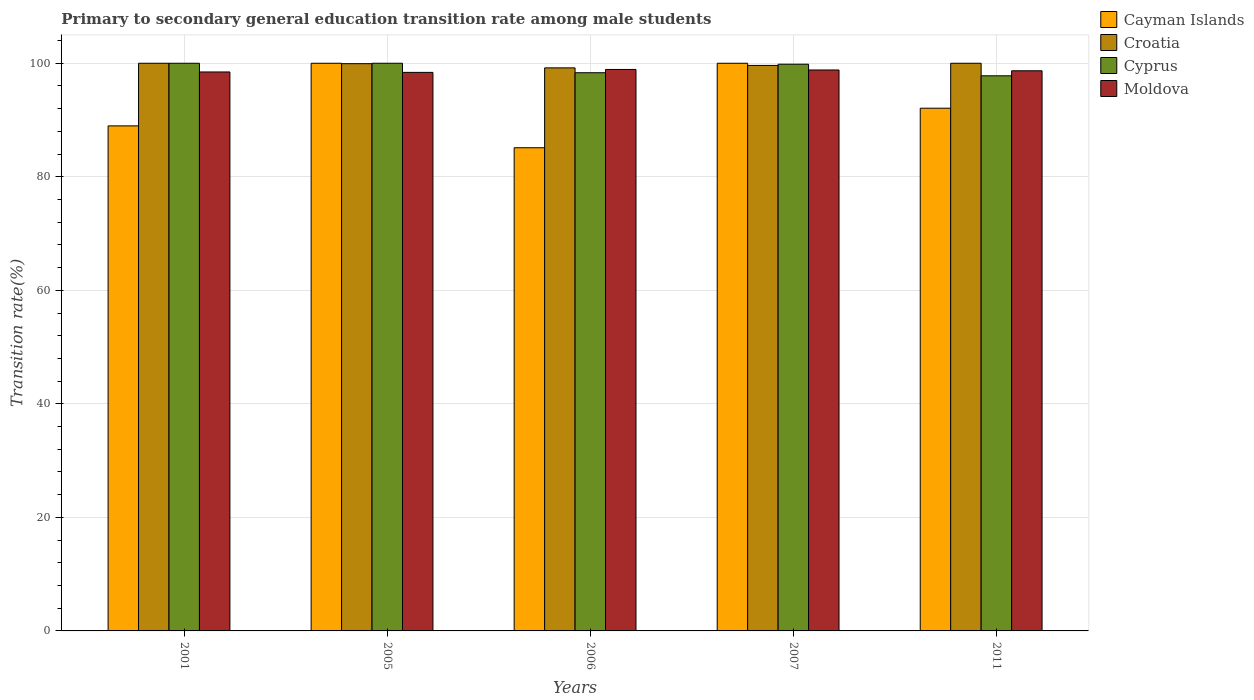How many different coloured bars are there?
Your answer should be compact. 4. How many groups of bars are there?
Provide a succinct answer. 5. How many bars are there on the 2nd tick from the right?
Offer a very short reply. 4. What is the label of the 1st group of bars from the left?
Your answer should be compact. 2001. In how many cases, is the number of bars for a given year not equal to the number of legend labels?
Your answer should be compact. 0. What is the transition rate in Moldova in 2007?
Give a very brief answer. 98.82. Across all years, what is the maximum transition rate in Cyprus?
Provide a succinct answer. 100. Across all years, what is the minimum transition rate in Cyprus?
Give a very brief answer. 97.79. In which year was the transition rate in Moldova minimum?
Your answer should be very brief. 2005. What is the total transition rate in Moldova in the graph?
Make the answer very short. 493.26. What is the difference between the transition rate in Croatia in 2006 and that in 2011?
Offer a terse response. -0.81. What is the difference between the transition rate in Cyprus in 2011 and the transition rate in Croatia in 2001?
Offer a very short reply. -2.21. What is the average transition rate in Croatia per year?
Keep it short and to the point. 99.75. In the year 2005, what is the difference between the transition rate in Croatia and transition rate in Cayman Islands?
Keep it short and to the point. -0.07. What is the ratio of the transition rate in Cyprus in 2001 to that in 2007?
Ensure brevity in your answer.  1. Is the transition rate in Cayman Islands in 2001 less than that in 2011?
Ensure brevity in your answer.  Yes. What is the difference between the highest and the lowest transition rate in Cyprus?
Keep it short and to the point. 2.21. In how many years, is the transition rate in Cayman Islands greater than the average transition rate in Cayman Islands taken over all years?
Keep it short and to the point. 2. Is the sum of the transition rate in Cyprus in 2005 and 2007 greater than the maximum transition rate in Cayman Islands across all years?
Ensure brevity in your answer.  Yes. Is it the case that in every year, the sum of the transition rate in Moldova and transition rate in Cayman Islands is greater than the sum of transition rate in Croatia and transition rate in Cyprus?
Offer a terse response. No. What does the 3rd bar from the left in 2006 represents?
Provide a short and direct response. Cyprus. What does the 3rd bar from the right in 2006 represents?
Provide a short and direct response. Croatia. How many bars are there?
Your answer should be compact. 20. Are all the bars in the graph horizontal?
Provide a succinct answer. No. Are the values on the major ticks of Y-axis written in scientific E-notation?
Give a very brief answer. No. Does the graph contain any zero values?
Provide a short and direct response. No. How many legend labels are there?
Give a very brief answer. 4. How are the legend labels stacked?
Offer a terse response. Vertical. What is the title of the graph?
Your answer should be compact. Primary to secondary general education transition rate among male students. Does "Nicaragua" appear as one of the legend labels in the graph?
Make the answer very short. No. What is the label or title of the X-axis?
Provide a succinct answer. Years. What is the label or title of the Y-axis?
Your answer should be very brief. Transition rate(%). What is the Transition rate(%) in Cayman Islands in 2001?
Provide a succinct answer. 88.97. What is the Transition rate(%) of Croatia in 2001?
Your answer should be very brief. 100. What is the Transition rate(%) in Moldova in 2001?
Keep it short and to the point. 98.47. What is the Transition rate(%) of Croatia in 2005?
Make the answer very short. 99.93. What is the Transition rate(%) of Moldova in 2005?
Your answer should be compact. 98.39. What is the Transition rate(%) in Cayman Islands in 2006?
Ensure brevity in your answer.  85.12. What is the Transition rate(%) of Croatia in 2006?
Make the answer very short. 99.19. What is the Transition rate(%) in Cyprus in 2006?
Give a very brief answer. 98.33. What is the Transition rate(%) of Moldova in 2006?
Ensure brevity in your answer.  98.91. What is the Transition rate(%) of Croatia in 2007?
Your answer should be very brief. 99.62. What is the Transition rate(%) of Cyprus in 2007?
Provide a succinct answer. 99.83. What is the Transition rate(%) of Moldova in 2007?
Your answer should be compact. 98.82. What is the Transition rate(%) of Cayman Islands in 2011?
Your response must be concise. 92.08. What is the Transition rate(%) in Cyprus in 2011?
Give a very brief answer. 97.79. What is the Transition rate(%) of Moldova in 2011?
Offer a very short reply. 98.67. Across all years, what is the maximum Transition rate(%) in Cayman Islands?
Make the answer very short. 100. Across all years, what is the maximum Transition rate(%) of Cyprus?
Your response must be concise. 100. Across all years, what is the maximum Transition rate(%) in Moldova?
Provide a succinct answer. 98.91. Across all years, what is the minimum Transition rate(%) in Cayman Islands?
Offer a very short reply. 85.12. Across all years, what is the minimum Transition rate(%) of Croatia?
Your answer should be very brief. 99.19. Across all years, what is the minimum Transition rate(%) in Cyprus?
Keep it short and to the point. 97.79. Across all years, what is the minimum Transition rate(%) of Moldova?
Ensure brevity in your answer.  98.39. What is the total Transition rate(%) of Cayman Islands in the graph?
Make the answer very short. 466.17. What is the total Transition rate(%) in Croatia in the graph?
Ensure brevity in your answer.  498.73. What is the total Transition rate(%) in Cyprus in the graph?
Give a very brief answer. 495.95. What is the total Transition rate(%) in Moldova in the graph?
Your answer should be compact. 493.26. What is the difference between the Transition rate(%) of Cayman Islands in 2001 and that in 2005?
Ensure brevity in your answer.  -11.03. What is the difference between the Transition rate(%) of Croatia in 2001 and that in 2005?
Give a very brief answer. 0.07. What is the difference between the Transition rate(%) of Cyprus in 2001 and that in 2005?
Give a very brief answer. 0. What is the difference between the Transition rate(%) of Moldova in 2001 and that in 2005?
Keep it short and to the point. 0.07. What is the difference between the Transition rate(%) of Cayman Islands in 2001 and that in 2006?
Offer a terse response. 3.85. What is the difference between the Transition rate(%) of Croatia in 2001 and that in 2006?
Make the answer very short. 0.81. What is the difference between the Transition rate(%) in Cyprus in 2001 and that in 2006?
Offer a very short reply. 1.67. What is the difference between the Transition rate(%) in Moldova in 2001 and that in 2006?
Offer a terse response. -0.44. What is the difference between the Transition rate(%) of Cayman Islands in 2001 and that in 2007?
Your response must be concise. -11.03. What is the difference between the Transition rate(%) of Croatia in 2001 and that in 2007?
Offer a very short reply. 0.38. What is the difference between the Transition rate(%) in Cyprus in 2001 and that in 2007?
Offer a terse response. 0.17. What is the difference between the Transition rate(%) in Moldova in 2001 and that in 2007?
Your response must be concise. -0.35. What is the difference between the Transition rate(%) of Cayman Islands in 2001 and that in 2011?
Provide a short and direct response. -3.11. What is the difference between the Transition rate(%) of Cyprus in 2001 and that in 2011?
Offer a very short reply. 2.21. What is the difference between the Transition rate(%) in Moldova in 2001 and that in 2011?
Offer a terse response. -0.21. What is the difference between the Transition rate(%) in Cayman Islands in 2005 and that in 2006?
Make the answer very short. 14.88. What is the difference between the Transition rate(%) in Croatia in 2005 and that in 2006?
Provide a short and direct response. 0.74. What is the difference between the Transition rate(%) in Cyprus in 2005 and that in 2006?
Your answer should be compact. 1.67. What is the difference between the Transition rate(%) of Moldova in 2005 and that in 2006?
Keep it short and to the point. -0.51. What is the difference between the Transition rate(%) in Croatia in 2005 and that in 2007?
Make the answer very short. 0.31. What is the difference between the Transition rate(%) in Cyprus in 2005 and that in 2007?
Your answer should be very brief. 0.17. What is the difference between the Transition rate(%) of Moldova in 2005 and that in 2007?
Offer a very short reply. -0.42. What is the difference between the Transition rate(%) of Cayman Islands in 2005 and that in 2011?
Offer a terse response. 7.92. What is the difference between the Transition rate(%) in Croatia in 2005 and that in 2011?
Offer a terse response. -0.07. What is the difference between the Transition rate(%) of Cyprus in 2005 and that in 2011?
Your answer should be very brief. 2.21. What is the difference between the Transition rate(%) of Moldova in 2005 and that in 2011?
Offer a terse response. -0.28. What is the difference between the Transition rate(%) of Cayman Islands in 2006 and that in 2007?
Your answer should be very brief. -14.88. What is the difference between the Transition rate(%) in Croatia in 2006 and that in 2007?
Give a very brief answer. -0.43. What is the difference between the Transition rate(%) of Cyprus in 2006 and that in 2007?
Your response must be concise. -1.5. What is the difference between the Transition rate(%) of Moldova in 2006 and that in 2007?
Your answer should be compact. 0.09. What is the difference between the Transition rate(%) of Cayman Islands in 2006 and that in 2011?
Make the answer very short. -6.97. What is the difference between the Transition rate(%) in Croatia in 2006 and that in 2011?
Provide a short and direct response. -0.81. What is the difference between the Transition rate(%) of Cyprus in 2006 and that in 2011?
Your answer should be very brief. 0.54. What is the difference between the Transition rate(%) in Moldova in 2006 and that in 2011?
Provide a short and direct response. 0.23. What is the difference between the Transition rate(%) in Cayman Islands in 2007 and that in 2011?
Ensure brevity in your answer.  7.92. What is the difference between the Transition rate(%) of Croatia in 2007 and that in 2011?
Provide a short and direct response. -0.38. What is the difference between the Transition rate(%) of Cyprus in 2007 and that in 2011?
Give a very brief answer. 2.04. What is the difference between the Transition rate(%) in Moldova in 2007 and that in 2011?
Keep it short and to the point. 0.14. What is the difference between the Transition rate(%) of Cayman Islands in 2001 and the Transition rate(%) of Croatia in 2005?
Ensure brevity in your answer.  -10.96. What is the difference between the Transition rate(%) of Cayman Islands in 2001 and the Transition rate(%) of Cyprus in 2005?
Ensure brevity in your answer.  -11.03. What is the difference between the Transition rate(%) in Cayman Islands in 2001 and the Transition rate(%) in Moldova in 2005?
Offer a very short reply. -9.43. What is the difference between the Transition rate(%) in Croatia in 2001 and the Transition rate(%) in Moldova in 2005?
Give a very brief answer. 1.61. What is the difference between the Transition rate(%) in Cyprus in 2001 and the Transition rate(%) in Moldova in 2005?
Your answer should be very brief. 1.61. What is the difference between the Transition rate(%) in Cayman Islands in 2001 and the Transition rate(%) in Croatia in 2006?
Provide a succinct answer. -10.22. What is the difference between the Transition rate(%) in Cayman Islands in 2001 and the Transition rate(%) in Cyprus in 2006?
Provide a short and direct response. -9.36. What is the difference between the Transition rate(%) in Cayman Islands in 2001 and the Transition rate(%) in Moldova in 2006?
Provide a succinct answer. -9.94. What is the difference between the Transition rate(%) of Croatia in 2001 and the Transition rate(%) of Cyprus in 2006?
Provide a short and direct response. 1.67. What is the difference between the Transition rate(%) in Croatia in 2001 and the Transition rate(%) in Moldova in 2006?
Offer a very short reply. 1.09. What is the difference between the Transition rate(%) of Cyprus in 2001 and the Transition rate(%) of Moldova in 2006?
Keep it short and to the point. 1.09. What is the difference between the Transition rate(%) in Cayman Islands in 2001 and the Transition rate(%) in Croatia in 2007?
Your response must be concise. -10.65. What is the difference between the Transition rate(%) in Cayman Islands in 2001 and the Transition rate(%) in Cyprus in 2007?
Keep it short and to the point. -10.86. What is the difference between the Transition rate(%) of Cayman Islands in 2001 and the Transition rate(%) of Moldova in 2007?
Make the answer very short. -9.85. What is the difference between the Transition rate(%) in Croatia in 2001 and the Transition rate(%) in Cyprus in 2007?
Offer a very short reply. 0.17. What is the difference between the Transition rate(%) of Croatia in 2001 and the Transition rate(%) of Moldova in 2007?
Your answer should be very brief. 1.18. What is the difference between the Transition rate(%) of Cyprus in 2001 and the Transition rate(%) of Moldova in 2007?
Offer a very short reply. 1.18. What is the difference between the Transition rate(%) of Cayman Islands in 2001 and the Transition rate(%) of Croatia in 2011?
Provide a succinct answer. -11.03. What is the difference between the Transition rate(%) in Cayman Islands in 2001 and the Transition rate(%) in Cyprus in 2011?
Provide a succinct answer. -8.82. What is the difference between the Transition rate(%) in Cayman Islands in 2001 and the Transition rate(%) in Moldova in 2011?
Provide a short and direct response. -9.71. What is the difference between the Transition rate(%) in Croatia in 2001 and the Transition rate(%) in Cyprus in 2011?
Your answer should be very brief. 2.21. What is the difference between the Transition rate(%) of Croatia in 2001 and the Transition rate(%) of Moldova in 2011?
Your answer should be compact. 1.33. What is the difference between the Transition rate(%) of Cyprus in 2001 and the Transition rate(%) of Moldova in 2011?
Make the answer very short. 1.33. What is the difference between the Transition rate(%) in Cayman Islands in 2005 and the Transition rate(%) in Croatia in 2006?
Make the answer very short. 0.81. What is the difference between the Transition rate(%) in Cayman Islands in 2005 and the Transition rate(%) in Cyprus in 2006?
Ensure brevity in your answer.  1.67. What is the difference between the Transition rate(%) of Cayman Islands in 2005 and the Transition rate(%) of Moldova in 2006?
Your answer should be very brief. 1.09. What is the difference between the Transition rate(%) of Croatia in 2005 and the Transition rate(%) of Cyprus in 2006?
Keep it short and to the point. 1.59. What is the difference between the Transition rate(%) in Croatia in 2005 and the Transition rate(%) in Moldova in 2006?
Provide a short and direct response. 1.02. What is the difference between the Transition rate(%) of Cyprus in 2005 and the Transition rate(%) of Moldova in 2006?
Your answer should be compact. 1.09. What is the difference between the Transition rate(%) of Cayman Islands in 2005 and the Transition rate(%) of Croatia in 2007?
Offer a terse response. 0.38. What is the difference between the Transition rate(%) in Cayman Islands in 2005 and the Transition rate(%) in Cyprus in 2007?
Make the answer very short. 0.17. What is the difference between the Transition rate(%) of Cayman Islands in 2005 and the Transition rate(%) of Moldova in 2007?
Your answer should be very brief. 1.18. What is the difference between the Transition rate(%) of Croatia in 2005 and the Transition rate(%) of Cyprus in 2007?
Offer a very short reply. 0.09. What is the difference between the Transition rate(%) in Croatia in 2005 and the Transition rate(%) in Moldova in 2007?
Your answer should be very brief. 1.11. What is the difference between the Transition rate(%) of Cyprus in 2005 and the Transition rate(%) of Moldova in 2007?
Offer a very short reply. 1.18. What is the difference between the Transition rate(%) of Cayman Islands in 2005 and the Transition rate(%) of Croatia in 2011?
Make the answer very short. 0. What is the difference between the Transition rate(%) of Cayman Islands in 2005 and the Transition rate(%) of Cyprus in 2011?
Offer a terse response. 2.21. What is the difference between the Transition rate(%) in Cayman Islands in 2005 and the Transition rate(%) in Moldova in 2011?
Offer a very short reply. 1.33. What is the difference between the Transition rate(%) in Croatia in 2005 and the Transition rate(%) in Cyprus in 2011?
Give a very brief answer. 2.14. What is the difference between the Transition rate(%) of Croatia in 2005 and the Transition rate(%) of Moldova in 2011?
Offer a very short reply. 1.25. What is the difference between the Transition rate(%) in Cyprus in 2005 and the Transition rate(%) in Moldova in 2011?
Provide a short and direct response. 1.33. What is the difference between the Transition rate(%) of Cayman Islands in 2006 and the Transition rate(%) of Croatia in 2007?
Make the answer very short. -14.5. What is the difference between the Transition rate(%) of Cayman Islands in 2006 and the Transition rate(%) of Cyprus in 2007?
Your answer should be very brief. -14.72. What is the difference between the Transition rate(%) in Cayman Islands in 2006 and the Transition rate(%) in Moldova in 2007?
Offer a very short reply. -13.7. What is the difference between the Transition rate(%) of Croatia in 2006 and the Transition rate(%) of Cyprus in 2007?
Your answer should be very brief. -0.65. What is the difference between the Transition rate(%) of Croatia in 2006 and the Transition rate(%) of Moldova in 2007?
Keep it short and to the point. 0.37. What is the difference between the Transition rate(%) in Cyprus in 2006 and the Transition rate(%) in Moldova in 2007?
Offer a terse response. -0.48. What is the difference between the Transition rate(%) in Cayman Islands in 2006 and the Transition rate(%) in Croatia in 2011?
Your response must be concise. -14.88. What is the difference between the Transition rate(%) in Cayman Islands in 2006 and the Transition rate(%) in Cyprus in 2011?
Give a very brief answer. -12.67. What is the difference between the Transition rate(%) of Cayman Islands in 2006 and the Transition rate(%) of Moldova in 2011?
Your response must be concise. -13.56. What is the difference between the Transition rate(%) in Croatia in 2006 and the Transition rate(%) in Cyprus in 2011?
Keep it short and to the point. 1.4. What is the difference between the Transition rate(%) in Croatia in 2006 and the Transition rate(%) in Moldova in 2011?
Offer a very short reply. 0.51. What is the difference between the Transition rate(%) in Cyprus in 2006 and the Transition rate(%) in Moldova in 2011?
Your answer should be compact. -0.34. What is the difference between the Transition rate(%) of Cayman Islands in 2007 and the Transition rate(%) of Croatia in 2011?
Your response must be concise. 0. What is the difference between the Transition rate(%) of Cayman Islands in 2007 and the Transition rate(%) of Cyprus in 2011?
Give a very brief answer. 2.21. What is the difference between the Transition rate(%) of Cayman Islands in 2007 and the Transition rate(%) of Moldova in 2011?
Give a very brief answer. 1.33. What is the difference between the Transition rate(%) in Croatia in 2007 and the Transition rate(%) in Cyprus in 2011?
Offer a terse response. 1.83. What is the difference between the Transition rate(%) in Croatia in 2007 and the Transition rate(%) in Moldova in 2011?
Provide a succinct answer. 0.94. What is the difference between the Transition rate(%) of Cyprus in 2007 and the Transition rate(%) of Moldova in 2011?
Make the answer very short. 1.16. What is the average Transition rate(%) in Cayman Islands per year?
Offer a very short reply. 93.23. What is the average Transition rate(%) of Croatia per year?
Your answer should be very brief. 99.75. What is the average Transition rate(%) in Cyprus per year?
Provide a short and direct response. 99.19. What is the average Transition rate(%) of Moldova per year?
Make the answer very short. 98.65. In the year 2001, what is the difference between the Transition rate(%) of Cayman Islands and Transition rate(%) of Croatia?
Your answer should be compact. -11.03. In the year 2001, what is the difference between the Transition rate(%) in Cayman Islands and Transition rate(%) in Cyprus?
Make the answer very short. -11.03. In the year 2001, what is the difference between the Transition rate(%) in Cayman Islands and Transition rate(%) in Moldova?
Your answer should be very brief. -9.5. In the year 2001, what is the difference between the Transition rate(%) of Croatia and Transition rate(%) of Moldova?
Provide a succinct answer. 1.53. In the year 2001, what is the difference between the Transition rate(%) in Cyprus and Transition rate(%) in Moldova?
Provide a succinct answer. 1.53. In the year 2005, what is the difference between the Transition rate(%) of Cayman Islands and Transition rate(%) of Croatia?
Provide a succinct answer. 0.07. In the year 2005, what is the difference between the Transition rate(%) in Cayman Islands and Transition rate(%) in Moldova?
Ensure brevity in your answer.  1.61. In the year 2005, what is the difference between the Transition rate(%) in Croatia and Transition rate(%) in Cyprus?
Offer a terse response. -0.07. In the year 2005, what is the difference between the Transition rate(%) of Croatia and Transition rate(%) of Moldova?
Give a very brief answer. 1.53. In the year 2005, what is the difference between the Transition rate(%) in Cyprus and Transition rate(%) in Moldova?
Keep it short and to the point. 1.61. In the year 2006, what is the difference between the Transition rate(%) in Cayman Islands and Transition rate(%) in Croatia?
Provide a succinct answer. -14.07. In the year 2006, what is the difference between the Transition rate(%) in Cayman Islands and Transition rate(%) in Cyprus?
Your response must be concise. -13.22. In the year 2006, what is the difference between the Transition rate(%) of Cayman Islands and Transition rate(%) of Moldova?
Offer a terse response. -13.79. In the year 2006, what is the difference between the Transition rate(%) in Croatia and Transition rate(%) in Cyprus?
Provide a short and direct response. 0.86. In the year 2006, what is the difference between the Transition rate(%) in Croatia and Transition rate(%) in Moldova?
Give a very brief answer. 0.28. In the year 2006, what is the difference between the Transition rate(%) in Cyprus and Transition rate(%) in Moldova?
Offer a terse response. -0.57. In the year 2007, what is the difference between the Transition rate(%) of Cayman Islands and Transition rate(%) of Croatia?
Keep it short and to the point. 0.38. In the year 2007, what is the difference between the Transition rate(%) in Cayman Islands and Transition rate(%) in Cyprus?
Provide a short and direct response. 0.17. In the year 2007, what is the difference between the Transition rate(%) of Cayman Islands and Transition rate(%) of Moldova?
Give a very brief answer. 1.18. In the year 2007, what is the difference between the Transition rate(%) of Croatia and Transition rate(%) of Cyprus?
Your answer should be very brief. -0.21. In the year 2007, what is the difference between the Transition rate(%) of Croatia and Transition rate(%) of Moldova?
Offer a terse response. 0.8. In the year 2007, what is the difference between the Transition rate(%) in Cyprus and Transition rate(%) in Moldova?
Provide a short and direct response. 1.02. In the year 2011, what is the difference between the Transition rate(%) of Cayman Islands and Transition rate(%) of Croatia?
Your answer should be compact. -7.92. In the year 2011, what is the difference between the Transition rate(%) of Cayman Islands and Transition rate(%) of Cyprus?
Give a very brief answer. -5.71. In the year 2011, what is the difference between the Transition rate(%) in Cayman Islands and Transition rate(%) in Moldova?
Make the answer very short. -6.59. In the year 2011, what is the difference between the Transition rate(%) in Croatia and Transition rate(%) in Cyprus?
Offer a very short reply. 2.21. In the year 2011, what is the difference between the Transition rate(%) in Croatia and Transition rate(%) in Moldova?
Keep it short and to the point. 1.33. In the year 2011, what is the difference between the Transition rate(%) of Cyprus and Transition rate(%) of Moldova?
Offer a terse response. -0.88. What is the ratio of the Transition rate(%) of Cayman Islands in 2001 to that in 2005?
Give a very brief answer. 0.89. What is the ratio of the Transition rate(%) of Moldova in 2001 to that in 2005?
Provide a short and direct response. 1. What is the ratio of the Transition rate(%) in Cayman Islands in 2001 to that in 2006?
Ensure brevity in your answer.  1.05. What is the ratio of the Transition rate(%) in Croatia in 2001 to that in 2006?
Offer a very short reply. 1.01. What is the ratio of the Transition rate(%) of Cyprus in 2001 to that in 2006?
Your answer should be very brief. 1.02. What is the ratio of the Transition rate(%) in Cayman Islands in 2001 to that in 2007?
Offer a terse response. 0.89. What is the ratio of the Transition rate(%) in Croatia in 2001 to that in 2007?
Keep it short and to the point. 1. What is the ratio of the Transition rate(%) of Moldova in 2001 to that in 2007?
Provide a succinct answer. 1. What is the ratio of the Transition rate(%) of Cayman Islands in 2001 to that in 2011?
Provide a short and direct response. 0.97. What is the ratio of the Transition rate(%) of Cyprus in 2001 to that in 2011?
Offer a terse response. 1.02. What is the ratio of the Transition rate(%) in Cayman Islands in 2005 to that in 2006?
Offer a very short reply. 1.17. What is the ratio of the Transition rate(%) of Croatia in 2005 to that in 2006?
Offer a very short reply. 1.01. What is the ratio of the Transition rate(%) in Cayman Islands in 2005 to that in 2007?
Keep it short and to the point. 1. What is the ratio of the Transition rate(%) of Croatia in 2005 to that in 2007?
Offer a terse response. 1. What is the ratio of the Transition rate(%) of Cayman Islands in 2005 to that in 2011?
Your answer should be very brief. 1.09. What is the ratio of the Transition rate(%) in Cyprus in 2005 to that in 2011?
Provide a short and direct response. 1.02. What is the ratio of the Transition rate(%) in Moldova in 2005 to that in 2011?
Keep it short and to the point. 1. What is the ratio of the Transition rate(%) in Cayman Islands in 2006 to that in 2007?
Offer a very short reply. 0.85. What is the ratio of the Transition rate(%) of Croatia in 2006 to that in 2007?
Provide a short and direct response. 1. What is the ratio of the Transition rate(%) in Moldova in 2006 to that in 2007?
Keep it short and to the point. 1. What is the ratio of the Transition rate(%) of Cayman Islands in 2006 to that in 2011?
Ensure brevity in your answer.  0.92. What is the ratio of the Transition rate(%) in Cyprus in 2006 to that in 2011?
Give a very brief answer. 1.01. What is the ratio of the Transition rate(%) in Moldova in 2006 to that in 2011?
Your answer should be compact. 1. What is the ratio of the Transition rate(%) in Cayman Islands in 2007 to that in 2011?
Keep it short and to the point. 1.09. What is the ratio of the Transition rate(%) of Cyprus in 2007 to that in 2011?
Ensure brevity in your answer.  1.02. What is the difference between the highest and the second highest Transition rate(%) in Cayman Islands?
Your response must be concise. 0. What is the difference between the highest and the second highest Transition rate(%) of Croatia?
Your answer should be very brief. 0. What is the difference between the highest and the second highest Transition rate(%) in Moldova?
Offer a terse response. 0.09. What is the difference between the highest and the lowest Transition rate(%) of Cayman Islands?
Keep it short and to the point. 14.88. What is the difference between the highest and the lowest Transition rate(%) of Croatia?
Keep it short and to the point. 0.81. What is the difference between the highest and the lowest Transition rate(%) of Cyprus?
Provide a succinct answer. 2.21. What is the difference between the highest and the lowest Transition rate(%) of Moldova?
Offer a terse response. 0.51. 